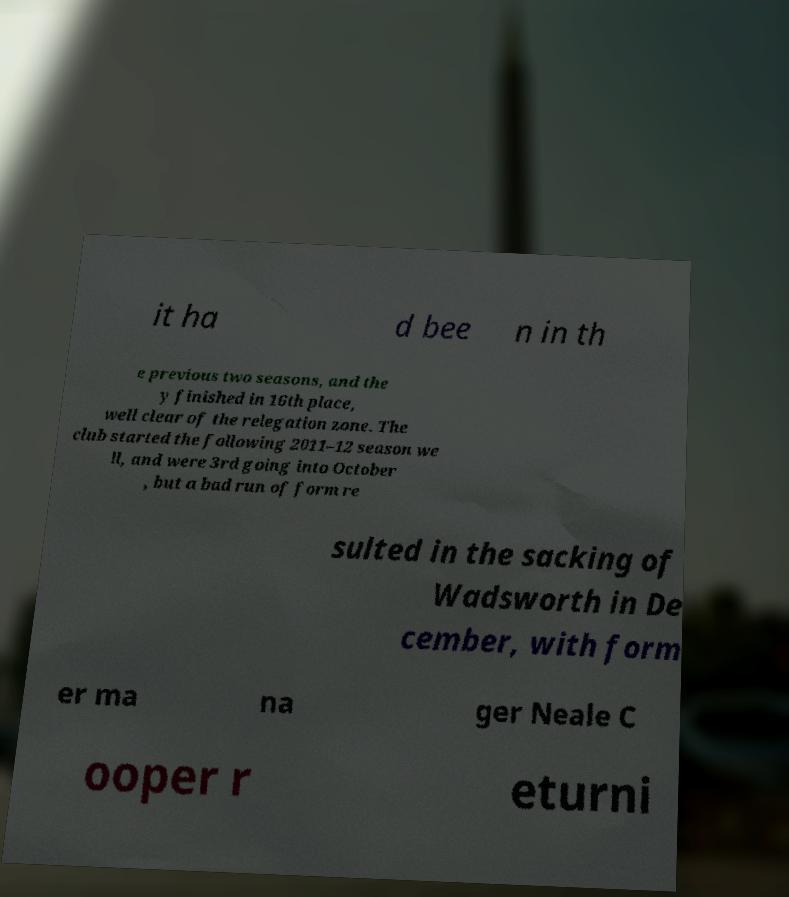There's text embedded in this image that I need extracted. Can you transcribe it verbatim? it ha d bee n in th e previous two seasons, and the y finished in 16th place, well clear of the relegation zone. The club started the following 2011–12 season we ll, and were 3rd going into October , but a bad run of form re sulted in the sacking of Wadsworth in De cember, with form er ma na ger Neale C ooper r eturni 